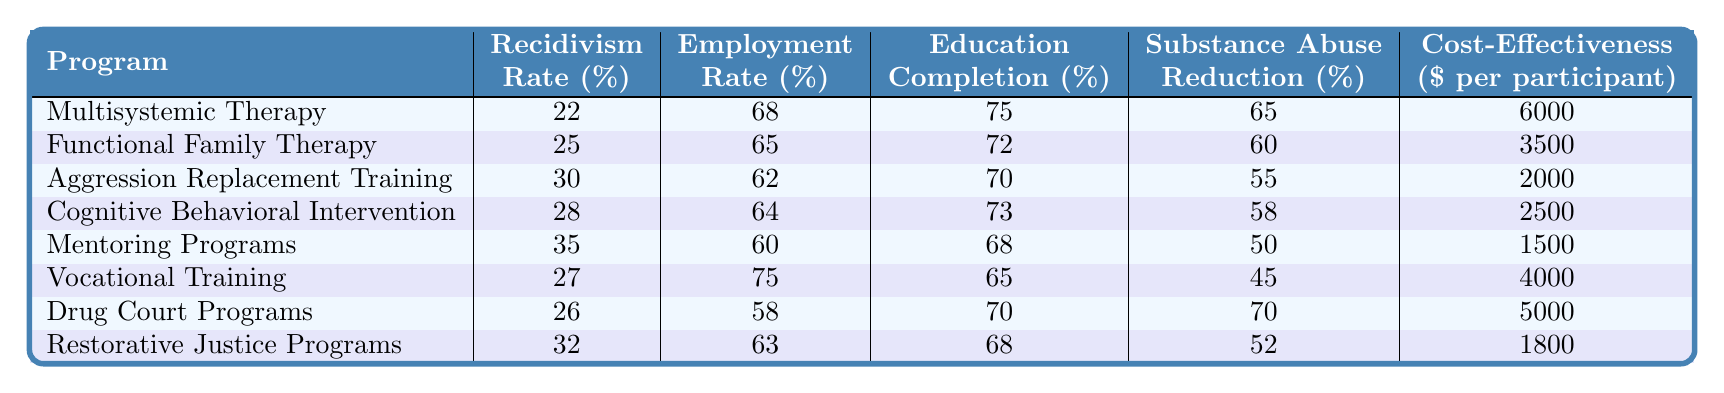What is the recidivism rate for Multisystemic Therapy? The recidivism rate is listed in the first row under the "Recidivism Rate (%)" column, which shows a value of 22%.
Answer: 22% Which rehabilitation program has the highest employment rate? In the "Employment Rate (%)" column, the highest value is 75% found in the "Vocational Training" row.
Answer: Vocational Training What is the average education completion rate across all programs? To find the average, we sum the education completion rates (75 + 72 + 70 + 73 + 68 + 65 + 70 + 68) =  496, and divide by the number of programs (8), giving us 496/8 = 62%.
Answer: 62% Does Aggression Replacement Training have a higher substance abuse reduction percentage than Mentoring Programs? From the "Substance Abuse Reduction (%)" column, Aggression Replacement Training has 55%, while Mentoring Programs has 50%. Since 55% is higher than 50%, the answer is yes.
Answer: Yes What is the cost-effectiveness difference between Functional Family Therapy and Drug Court Programs? Functional Family Therapy costs $3,500 per participant and Drug Court Programs cost $5,000. The difference is calculated as $5,000 - $3,500 = $1,500.
Answer: $1,500 Which program has the lowest recidivism rate? By examining the "Recidivism Rate (%)" column, the lowest value is 22%, which corresponds to Multisystemic Therapy.
Answer: Multisystemic Therapy What is the total substance abuse reduction percentage for all programs? We sum the values in the "Substance Abuse Reduction (%)" column: (65 + 60 + 55 + 58 + 50 + 45 + 70 + 52) =  365%.
Answer: 365% Which program has a higher employment rate, Drug Court Programs or Restorative Justice Programs? The employment rates are 58% for Drug Court Programs and 63% for Restorative Justice Programs. Since 63% is higher than 58%, the answer is Restorative Justice Programs.
Answer: Restorative Justice Programs What percentage of education completion does Vocational Training report, and how does it compare to the program with the lowest rate? Vocational Training has an education completion rate of 65%. The program with the lowest rate is Mentoring Programs at 68%. Since 65% is lower, Vocational Training has a lower percentage.
Answer: Lower What is the median cost-effectiveness among the rehabilitation programs? To find the median, we first list the costs in ascending order: $1,500, $2,000, $2,500, $3,500, $4,000, $5,000, $5,500, and $6,000. The median is the average of the 4th and 5th values: ($2,500 + $3,500)/2 = $3,000.
Answer: $3,000 